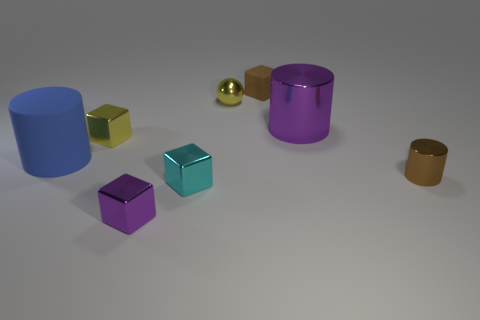There is a rubber thing that is the same color as the small cylinder; what is its shape?
Offer a very short reply. Cube. What is the large object that is on the right side of the cylinder that is on the left side of the small yellow metal object on the left side of the tiny metallic ball made of?
Your response must be concise. Metal. There is a purple block that is made of the same material as the yellow cube; what size is it?
Provide a succinct answer. Small. Is there a cylinder of the same color as the big shiny object?
Your answer should be very brief. No. There is a ball; is it the same size as the shiny cylinder that is in front of the large metal thing?
Offer a terse response. Yes. What number of purple shiny blocks are left of the small metal cube that is on the left side of the tiny metallic block that is in front of the cyan metal cube?
Ensure brevity in your answer.  0. There is a thing that is the same color as the small cylinder; what size is it?
Your answer should be very brief. Small. Are there any shiny spheres on the left side of the tiny cylinder?
Give a very brief answer. Yes. The brown rubber object has what shape?
Give a very brief answer. Cube. What shape is the thing that is behind the small yellow thing behind the large cylinder right of the brown rubber thing?
Give a very brief answer. Cube. 